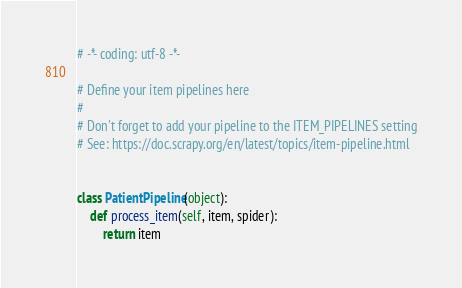Convert code to text. <code><loc_0><loc_0><loc_500><loc_500><_Python_># -*- coding: utf-8 -*-

# Define your item pipelines here
#
# Don't forget to add your pipeline to the ITEM_PIPELINES setting
# See: https://doc.scrapy.org/en/latest/topics/item-pipeline.html


class PatientPipeline(object):
    def process_item(self, item, spider):
        return item
</code> 